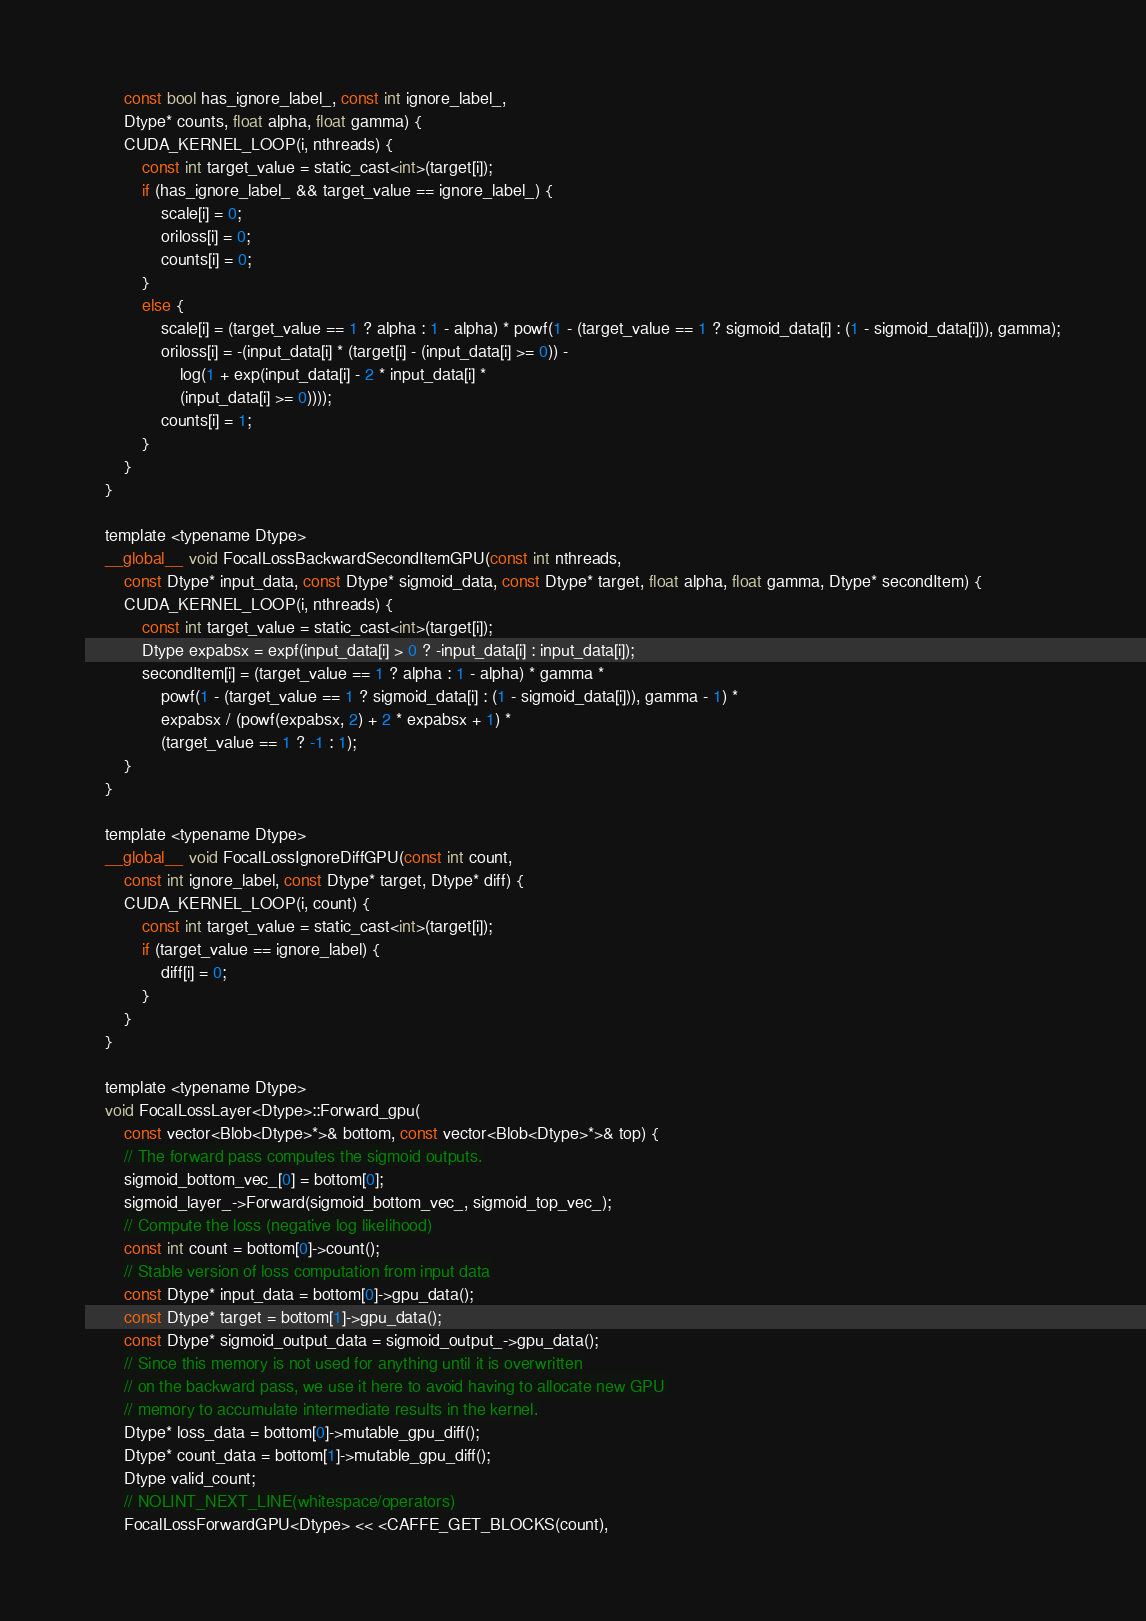<code> <loc_0><loc_0><loc_500><loc_500><_Cuda_>		const bool has_ignore_label_, const int ignore_label_,
		Dtype* counts, float alpha, float gamma) {
		CUDA_KERNEL_LOOP(i, nthreads) {
			const int target_value = static_cast<int>(target[i]);
			if (has_ignore_label_ && target_value == ignore_label_) {
				scale[i] = 0;
				oriloss[i] = 0;
				counts[i] = 0;
			}
			else {
				scale[i] = (target_value == 1 ? alpha : 1 - alpha) * powf(1 - (target_value == 1 ? sigmoid_data[i] : (1 - sigmoid_data[i])), gamma);
				oriloss[i] = -(input_data[i] * (target[i] - (input_data[i] >= 0)) -
					log(1 + exp(input_data[i] - 2 * input_data[i] *
					(input_data[i] >= 0))));
				counts[i] = 1;
			}
		}
	}

	template <typename Dtype>
	__global__ void FocalLossBackwardSecondItemGPU(const int nthreads,
		const Dtype* input_data, const Dtype* sigmoid_data, const Dtype* target, float alpha, float gamma, Dtype* secondItem) {
		CUDA_KERNEL_LOOP(i, nthreads) {
			const int target_value = static_cast<int>(target[i]);
			Dtype expabsx = expf(input_data[i] > 0 ? -input_data[i] : input_data[i]);
			secondItem[i] = (target_value == 1 ? alpha : 1 - alpha) * gamma *
				powf(1 - (target_value == 1 ? sigmoid_data[i] : (1 - sigmoid_data[i])), gamma - 1) *
				expabsx / (powf(expabsx, 2) + 2 * expabsx + 1) *
				(target_value == 1 ? -1 : 1);
		}
	}

	template <typename Dtype>
	__global__ void FocalLossIgnoreDiffGPU(const int count,
		const int ignore_label, const Dtype* target, Dtype* diff) {
		CUDA_KERNEL_LOOP(i, count) {
			const int target_value = static_cast<int>(target[i]);
			if (target_value == ignore_label) {
				diff[i] = 0;
			}
		}
	}

	template <typename Dtype>
	void FocalLossLayer<Dtype>::Forward_gpu(
		const vector<Blob<Dtype>*>& bottom, const vector<Blob<Dtype>*>& top) {
		// The forward pass computes the sigmoid outputs.
		sigmoid_bottom_vec_[0] = bottom[0];
		sigmoid_layer_->Forward(sigmoid_bottom_vec_, sigmoid_top_vec_);
		// Compute the loss (negative log likelihood)
		const int count = bottom[0]->count();
		// Stable version of loss computation from input data
		const Dtype* input_data = bottom[0]->gpu_data();
		const Dtype* target = bottom[1]->gpu_data();
		const Dtype* sigmoid_output_data = sigmoid_output_->gpu_data();
		// Since this memory is not used for anything until it is overwritten
		// on the backward pass, we use it here to avoid having to allocate new GPU
		// memory to accumulate intermediate results in the kernel.
		Dtype* loss_data = bottom[0]->mutable_gpu_diff();
		Dtype* count_data = bottom[1]->mutable_gpu_diff();
		Dtype valid_count;
		// NOLINT_NEXT_LINE(whitespace/operators)
		FocalLossForwardGPU<Dtype> << <CAFFE_GET_BLOCKS(count),</code> 